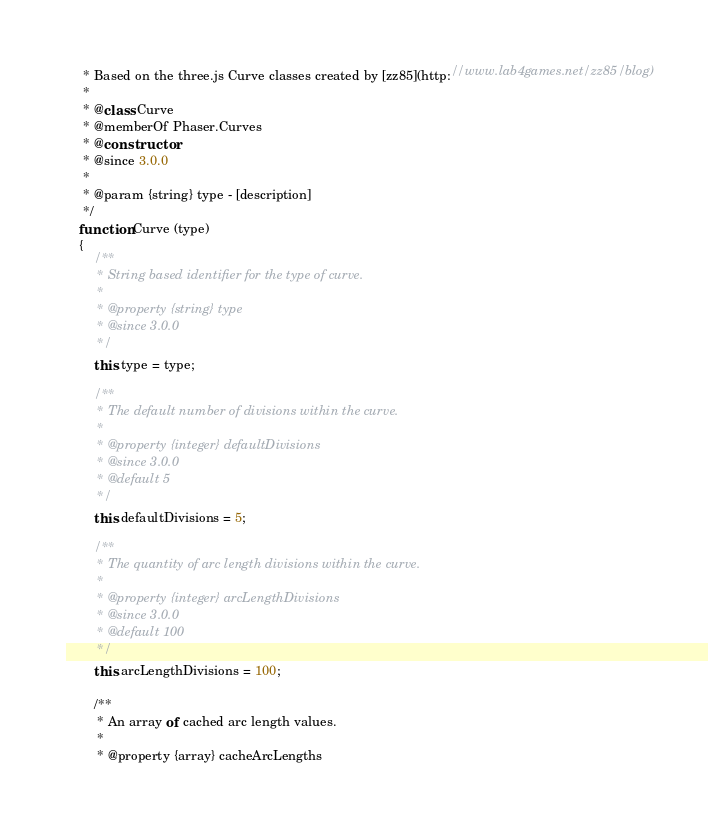Convert code to text. <code><loc_0><loc_0><loc_500><loc_500><_JavaScript_>     * Based on the three.js Curve classes created by [zz85](http://www.lab4games.net/zz85/blog)
     *
     * @class Curve
     * @memberOf Phaser.Curves
     * @constructor
     * @since 3.0.0
     *
     * @param {string} type - [description]
     */
    function Curve (type)
    {
        /**
         * String based identifier for the type of curve.
         *
         * @property {string} type
         * @since 3.0.0
         */
        this.type = type;

        /**
         * The default number of divisions within the curve.
         *
         * @property {integer} defaultDivisions
         * @since 3.0.0
         * @default 5
         */
        this.defaultDivisions = 5;

        /**
         * The quantity of arc length divisions within the curve.
         *
         * @property {integer} arcLengthDivisions
         * @since 3.0.0
         * @default 100
         */
        this.arcLengthDivisions = 100;

        /**
         * An array of cached arc length values.
         *
         * @property {array} cacheArcLengths</code> 